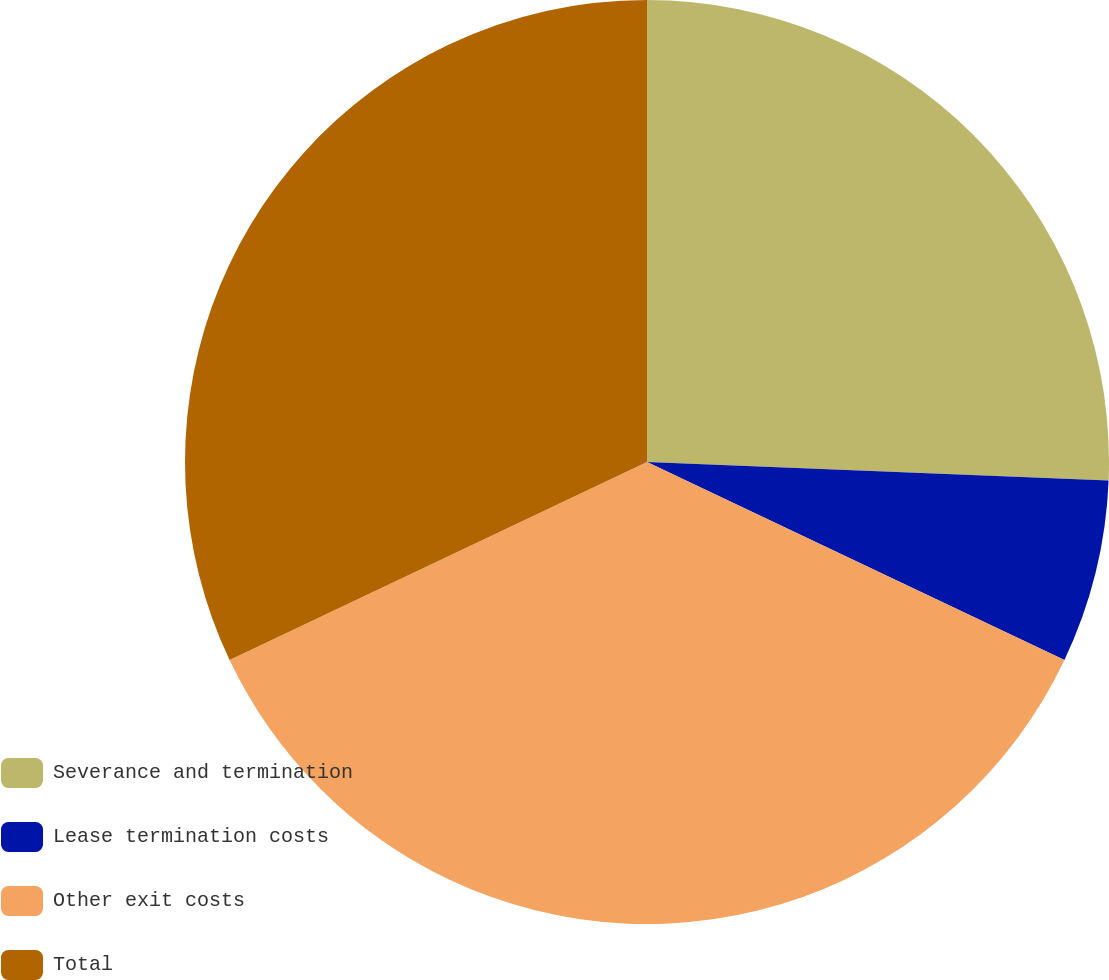<chart> <loc_0><loc_0><loc_500><loc_500><pie_chart><fcel>Severance and termination<fcel>Lease termination costs<fcel>Other exit costs<fcel>Total<nl><fcel>25.64%<fcel>6.41%<fcel>35.9%<fcel>32.05%<nl></chart> 